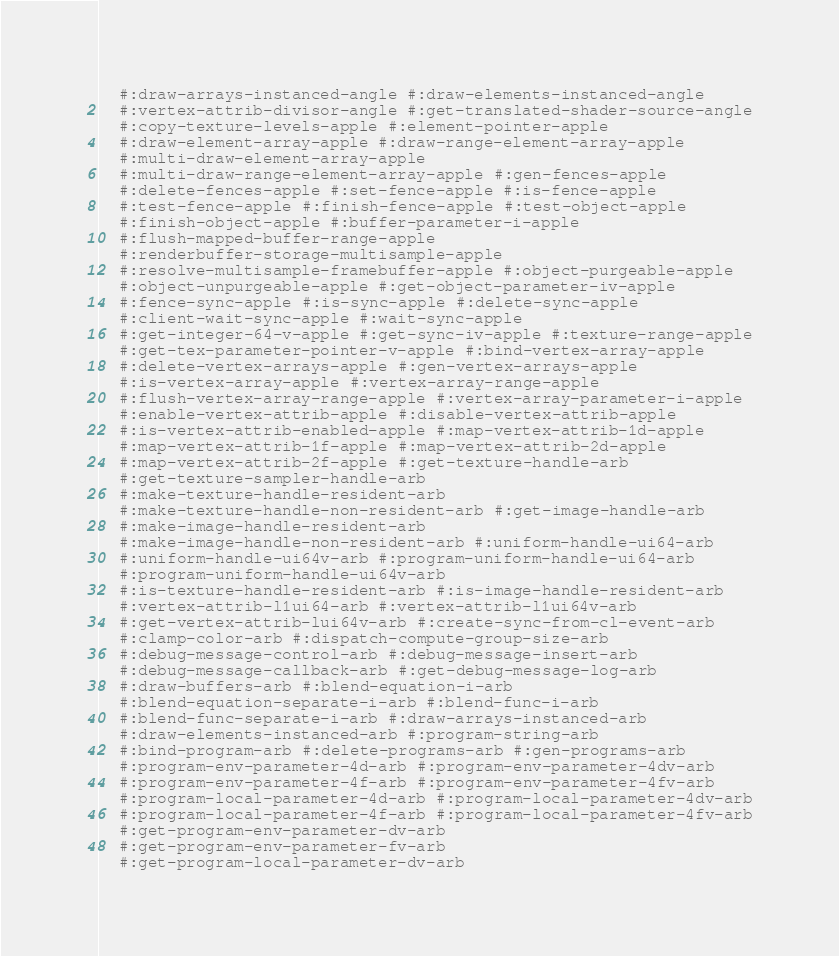<code> <loc_0><loc_0><loc_500><loc_500><_Lisp_>  #:draw-arrays-instanced-angle #:draw-elements-instanced-angle
  #:vertex-attrib-divisor-angle #:get-translated-shader-source-angle
  #:copy-texture-levels-apple #:element-pointer-apple
  #:draw-element-array-apple #:draw-range-element-array-apple
  #:multi-draw-element-array-apple
  #:multi-draw-range-element-array-apple #:gen-fences-apple
  #:delete-fences-apple #:set-fence-apple #:is-fence-apple
  #:test-fence-apple #:finish-fence-apple #:test-object-apple
  #:finish-object-apple #:buffer-parameter-i-apple
  #:flush-mapped-buffer-range-apple
  #:renderbuffer-storage-multisample-apple
  #:resolve-multisample-framebuffer-apple #:object-purgeable-apple
  #:object-unpurgeable-apple #:get-object-parameter-iv-apple
  #:fence-sync-apple #:is-sync-apple #:delete-sync-apple
  #:client-wait-sync-apple #:wait-sync-apple
  #:get-integer-64-v-apple #:get-sync-iv-apple #:texture-range-apple
  #:get-tex-parameter-pointer-v-apple #:bind-vertex-array-apple
  #:delete-vertex-arrays-apple #:gen-vertex-arrays-apple
  #:is-vertex-array-apple #:vertex-array-range-apple
  #:flush-vertex-array-range-apple #:vertex-array-parameter-i-apple
  #:enable-vertex-attrib-apple #:disable-vertex-attrib-apple
  #:is-vertex-attrib-enabled-apple #:map-vertex-attrib-1d-apple
  #:map-vertex-attrib-1f-apple #:map-vertex-attrib-2d-apple
  #:map-vertex-attrib-2f-apple #:get-texture-handle-arb
  #:get-texture-sampler-handle-arb
  #:make-texture-handle-resident-arb
  #:make-texture-handle-non-resident-arb #:get-image-handle-arb
  #:make-image-handle-resident-arb
  #:make-image-handle-non-resident-arb #:uniform-handle-ui64-arb
  #:uniform-handle-ui64v-arb #:program-uniform-handle-ui64-arb
  #:program-uniform-handle-ui64v-arb
  #:is-texture-handle-resident-arb #:is-image-handle-resident-arb
  #:vertex-attrib-l1ui64-arb #:vertex-attrib-l1ui64v-arb
  #:get-vertex-attrib-lui64v-arb #:create-sync-from-cl-event-arb
  #:clamp-color-arb #:dispatch-compute-group-size-arb
  #:debug-message-control-arb #:debug-message-insert-arb
  #:debug-message-callback-arb #:get-debug-message-log-arb
  #:draw-buffers-arb #:blend-equation-i-arb
  #:blend-equation-separate-i-arb #:blend-func-i-arb
  #:blend-func-separate-i-arb #:draw-arrays-instanced-arb
  #:draw-elements-instanced-arb #:program-string-arb
  #:bind-program-arb #:delete-programs-arb #:gen-programs-arb
  #:program-env-parameter-4d-arb #:program-env-parameter-4dv-arb
  #:program-env-parameter-4f-arb #:program-env-parameter-4fv-arb
  #:program-local-parameter-4d-arb #:program-local-parameter-4dv-arb
  #:program-local-parameter-4f-arb #:program-local-parameter-4fv-arb
  #:get-program-env-parameter-dv-arb
  #:get-program-env-parameter-fv-arb
  #:get-program-local-parameter-dv-arb</code> 